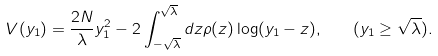Convert formula to latex. <formula><loc_0><loc_0><loc_500><loc_500>V ( y _ { 1 } ) = \frac { 2 N } { \lambda } y _ { 1 } ^ { 2 } - 2 \int _ { - \sqrt { \lambda } } ^ { \sqrt { \lambda } } d z \rho ( z ) \log ( y _ { 1 } - z ) , \quad ( y _ { 1 } \geq \sqrt { \lambda } ) .</formula> 